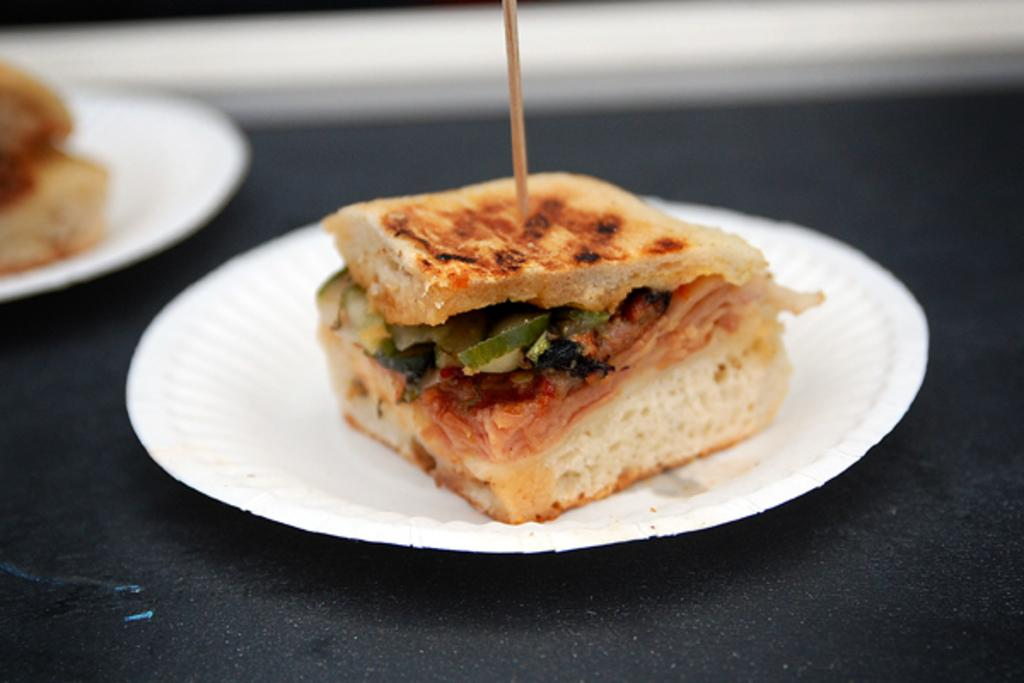What type of food is visible in the image? There is sandwich bread in the image. How is the sandwich bread presented? The sandwich bread is on a white plate. What is the color of the surface beneath the white plate? The white plate is on a black surface. What is used to hold the sandwich bread together? There is a toothpick on the sandwich bread. What type of soda is being served in a brass container in the image? There is no soda or brass container present in the image; it only features sandwich bread on a white plate. 